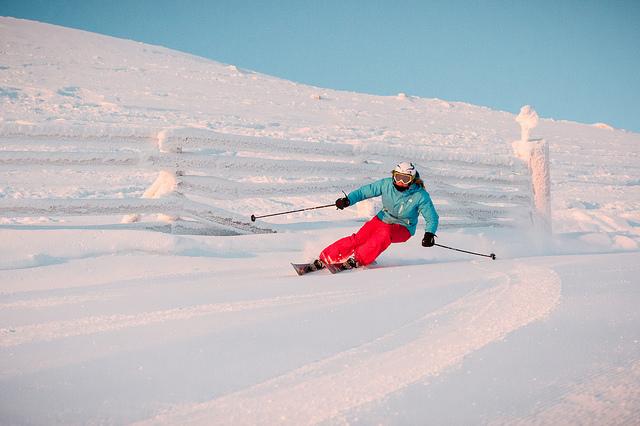Is the person on a snowboard?
Keep it brief. No. What is this person standing on?
Give a very brief answer. Skis. What color are his trousers?
Give a very brief answer. Red. What is she holding in her right hand?
Quick response, please. Ski pole. How many people are skiing?
Concise answer only. 1. Is the snow in this photo natural or man made?
Quick response, please. Natural. Is the snow deep?
Short answer required. Yes. What color is the girl's pants?
Be succinct. Red. What color is the person's jacket?
Give a very brief answer. Blue. How many people are shown?
Keep it brief. 1. What color are the pants?
Concise answer only. Red. Is the lady skiing in the city?
Concise answer only. No. Is this person skiing around obstacles?
Write a very short answer. No. What color is the coat?
Keep it brief. Blue. Is the woman heading downhill?
Be succinct. Yes. Is the entire area covered with snow?
Answer briefly. Yes. Is this a ski tow?
Keep it brief. No. Is this a man or woman?
Be succinct. Woman. What color is that man wearing?
Concise answer only. Blue. What color jacket is the person wearing the pink pants have on?
Give a very brief answer. Blue. Is there a ski lift in the photo?
Quick response, please. No. How many poles are they using?
Answer briefly. 2. How many white circles are on the skiers shirt?
Short answer required. 1. What is the girl wearing on her head?
Quick response, please. Helmet. What is the person doing?
Give a very brief answer. Skiing. Did they fall?
Give a very brief answer. No. Is there snow on the holy ground?
Quick response, please. Yes. What color are the boy's pants?
Keep it brief. Red. Is the skier going down a slope?
Be succinct. Yes. Where are the snow?
Answer briefly. Ground. 